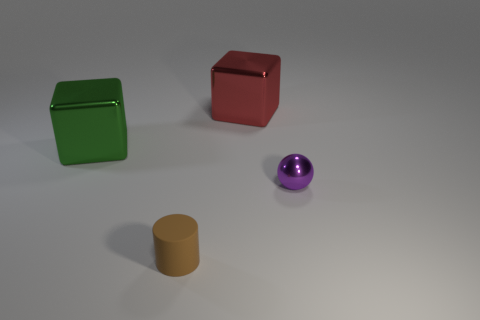Add 1 gray spheres. How many objects exist? 5 Subtract 0 green spheres. How many objects are left? 4 Subtract all cylinders. How many objects are left? 3 Subtract all red balls. Subtract all gray blocks. How many balls are left? 1 Subtract all gray balls. How many red cubes are left? 1 Subtract all tiny brown rubber cylinders. Subtract all tiny brown things. How many objects are left? 2 Add 1 big green shiny cubes. How many big green shiny cubes are left? 2 Add 2 big green shiny objects. How many big green shiny objects exist? 3 